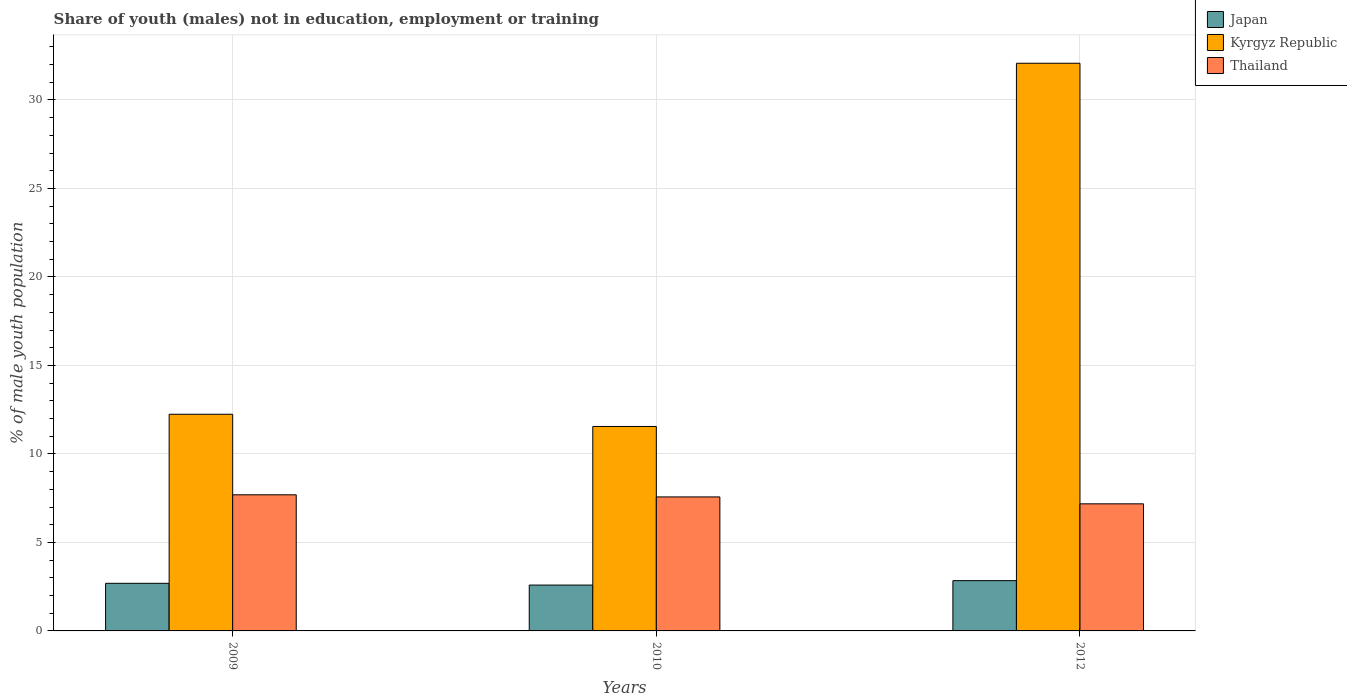Are the number of bars on each tick of the X-axis equal?
Offer a very short reply. Yes. How many bars are there on the 2nd tick from the left?
Give a very brief answer. 3. In how many cases, is the number of bars for a given year not equal to the number of legend labels?
Your answer should be compact. 0. What is the percentage of unemployed males population in in Thailand in 2012?
Provide a short and direct response. 7.18. Across all years, what is the maximum percentage of unemployed males population in in Thailand?
Make the answer very short. 7.69. Across all years, what is the minimum percentage of unemployed males population in in Kyrgyz Republic?
Offer a very short reply. 11.55. What is the total percentage of unemployed males population in in Japan in the graph?
Provide a succinct answer. 8.12. What is the difference between the percentage of unemployed males population in in Japan in 2009 and that in 2010?
Offer a very short reply. 0.1. What is the difference between the percentage of unemployed males population in in Kyrgyz Republic in 2009 and the percentage of unemployed males population in in Japan in 2012?
Your answer should be very brief. 9.4. What is the average percentage of unemployed males population in in Kyrgyz Republic per year?
Your answer should be very brief. 18.62. In the year 2012, what is the difference between the percentage of unemployed males population in in Thailand and percentage of unemployed males population in in Japan?
Ensure brevity in your answer.  4.34. What is the ratio of the percentage of unemployed males population in in Japan in 2009 to that in 2012?
Keep it short and to the point. 0.95. Is the percentage of unemployed males population in in Thailand in 2009 less than that in 2010?
Provide a short and direct response. No. Is the difference between the percentage of unemployed males population in in Thailand in 2010 and 2012 greater than the difference between the percentage of unemployed males population in in Japan in 2010 and 2012?
Your answer should be very brief. Yes. What is the difference between the highest and the second highest percentage of unemployed males population in in Thailand?
Make the answer very short. 0.12. What is the difference between the highest and the lowest percentage of unemployed males population in in Thailand?
Make the answer very short. 0.51. In how many years, is the percentage of unemployed males population in in Japan greater than the average percentage of unemployed males population in in Japan taken over all years?
Offer a very short reply. 1. What does the 2nd bar from the left in 2009 represents?
Give a very brief answer. Kyrgyz Republic. How many bars are there?
Ensure brevity in your answer.  9. Are all the bars in the graph horizontal?
Provide a short and direct response. No. Are the values on the major ticks of Y-axis written in scientific E-notation?
Your answer should be very brief. No. Does the graph contain any zero values?
Keep it short and to the point. No. How many legend labels are there?
Make the answer very short. 3. How are the legend labels stacked?
Offer a very short reply. Vertical. What is the title of the graph?
Offer a very short reply. Share of youth (males) not in education, employment or training. What is the label or title of the X-axis?
Offer a terse response. Years. What is the label or title of the Y-axis?
Keep it short and to the point. % of male youth population. What is the % of male youth population in Japan in 2009?
Make the answer very short. 2.69. What is the % of male youth population in Kyrgyz Republic in 2009?
Keep it short and to the point. 12.24. What is the % of male youth population of Thailand in 2009?
Keep it short and to the point. 7.69. What is the % of male youth population of Japan in 2010?
Your answer should be very brief. 2.59. What is the % of male youth population in Kyrgyz Republic in 2010?
Provide a short and direct response. 11.55. What is the % of male youth population in Thailand in 2010?
Ensure brevity in your answer.  7.57. What is the % of male youth population of Japan in 2012?
Provide a succinct answer. 2.84. What is the % of male youth population in Kyrgyz Republic in 2012?
Offer a very short reply. 32.07. What is the % of male youth population of Thailand in 2012?
Give a very brief answer. 7.18. Across all years, what is the maximum % of male youth population in Japan?
Provide a short and direct response. 2.84. Across all years, what is the maximum % of male youth population of Kyrgyz Republic?
Provide a succinct answer. 32.07. Across all years, what is the maximum % of male youth population in Thailand?
Your answer should be very brief. 7.69. Across all years, what is the minimum % of male youth population in Japan?
Give a very brief answer. 2.59. Across all years, what is the minimum % of male youth population in Kyrgyz Republic?
Make the answer very short. 11.55. Across all years, what is the minimum % of male youth population in Thailand?
Offer a very short reply. 7.18. What is the total % of male youth population of Japan in the graph?
Make the answer very short. 8.12. What is the total % of male youth population of Kyrgyz Republic in the graph?
Make the answer very short. 55.86. What is the total % of male youth population in Thailand in the graph?
Provide a short and direct response. 22.44. What is the difference between the % of male youth population of Kyrgyz Republic in 2009 and that in 2010?
Your response must be concise. 0.69. What is the difference between the % of male youth population of Thailand in 2009 and that in 2010?
Your response must be concise. 0.12. What is the difference between the % of male youth population of Kyrgyz Republic in 2009 and that in 2012?
Offer a terse response. -19.83. What is the difference between the % of male youth population of Thailand in 2009 and that in 2012?
Ensure brevity in your answer.  0.51. What is the difference between the % of male youth population in Japan in 2010 and that in 2012?
Provide a succinct answer. -0.25. What is the difference between the % of male youth population of Kyrgyz Republic in 2010 and that in 2012?
Provide a succinct answer. -20.52. What is the difference between the % of male youth population of Thailand in 2010 and that in 2012?
Give a very brief answer. 0.39. What is the difference between the % of male youth population in Japan in 2009 and the % of male youth population in Kyrgyz Republic in 2010?
Provide a succinct answer. -8.86. What is the difference between the % of male youth population of Japan in 2009 and the % of male youth population of Thailand in 2010?
Your answer should be very brief. -4.88. What is the difference between the % of male youth population in Kyrgyz Republic in 2009 and the % of male youth population in Thailand in 2010?
Keep it short and to the point. 4.67. What is the difference between the % of male youth population of Japan in 2009 and the % of male youth population of Kyrgyz Republic in 2012?
Your answer should be very brief. -29.38. What is the difference between the % of male youth population of Japan in 2009 and the % of male youth population of Thailand in 2012?
Give a very brief answer. -4.49. What is the difference between the % of male youth population of Kyrgyz Republic in 2009 and the % of male youth population of Thailand in 2012?
Offer a terse response. 5.06. What is the difference between the % of male youth population of Japan in 2010 and the % of male youth population of Kyrgyz Republic in 2012?
Give a very brief answer. -29.48. What is the difference between the % of male youth population of Japan in 2010 and the % of male youth population of Thailand in 2012?
Your answer should be compact. -4.59. What is the difference between the % of male youth population in Kyrgyz Republic in 2010 and the % of male youth population in Thailand in 2012?
Offer a very short reply. 4.37. What is the average % of male youth population of Japan per year?
Offer a very short reply. 2.71. What is the average % of male youth population of Kyrgyz Republic per year?
Ensure brevity in your answer.  18.62. What is the average % of male youth population in Thailand per year?
Make the answer very short. 7.48. In the year 2009, what is the difference between the % of male youth population of Japan and % of male youth population of Kyrgyz Republic?
Your answer should be compact. -9.55. In the year 2009, what is the difference between the % of male youth population in Kyrgyz Republic and % of male youth population in Thailand?
Offer a very short reply. 4.55. In the year 2010, what is the difference between the % of male youth population of Japan and % of male youth population of Kyrgyz Republic?
Provide a succinct answer. -8.96. In the year 2010, what is the difference between the % of male youth population of Japan and % of male youth population of Thailand?
Make the answer very short. -4.98. In the year 2010, what is the difference between the % of male youth population of Kyrgyz Republic and % of male youth population of Thailand?
Make the answer very short. 3.98. In the year 2012, what is the difference between the % of male youth population in Japan and % of male youth population in Kyrgyz Republic?
Make the answer very short. -29.23. In the year 2012, what is the difference between the % of male youth population in Japan and % of male youth population in Thailand?
Provide a short and direct response. -4.34. In the year 2012, what is the difference between the % of male youth population of Kyrgyz Republic and % of male youth population of Thailand?
Your response must be concise. 24.89. What is the ratio of the % of male youth population in Japan in 2009 to that in 2010?
Your answer should be compact. 1.04. What is the ratio of the % of male youth population in Kyrgyz Republic in 2009 to that in 2010?
Your answer should be compact. 1.06. What is the ratio of the % of male youth population of Thailand in 2009 to that in 2010?
Offer a terse response. 1.02. What is the ratio of the % of male youth population of Japan in 2009 to that in 2012?
Give a very brief answer. 0.95. What is the ratio of the % of male youth population of Kyrgyz Republic in 2009 to that in 2012?
Offer a very short reply. 0.38. What is the ratio of the % of male youth population of Thailand in 2009 to that in 2012?
Ensure brevity in your answer.  1.07. What is the ratio of the % of male youth population of Japan in 2010 to that in 2012?
Offer a terse response. 0.91. What is the ratio of the % of male youth population in Kyrgyz Republic in 2010 to that in 2012?
Provide a short and direct response. 0.36. What is the ratio of the % of male youth population in Thailand in 2010 to that in 2012?
Your answer should be compact. 1.05. What is the difference between the highest and the second highest % of male youth population of Japan?
Ensure brevity in your answer.  0.15. What is the difference between the highest and the second highest % of male youth population of Kyrgyz Republic?
Your answer should be very brief. 19.83. What is the difference between the highest and the second highest % of male youth population of Thailand?
Your answer should be very brief. 0.12. What is the difference between the highest and the lowest % of male youth population of Japan?
Keep it short and to the point. 0.25. What is the difference between the highest and the lowest % of male youth population of Kyrgyz Republic?
Offer a terse response. 20.52. What is the difference between the highest and the lowest % of male youth population of Thailand?
Ensure brevity in your answer.  0.51. 